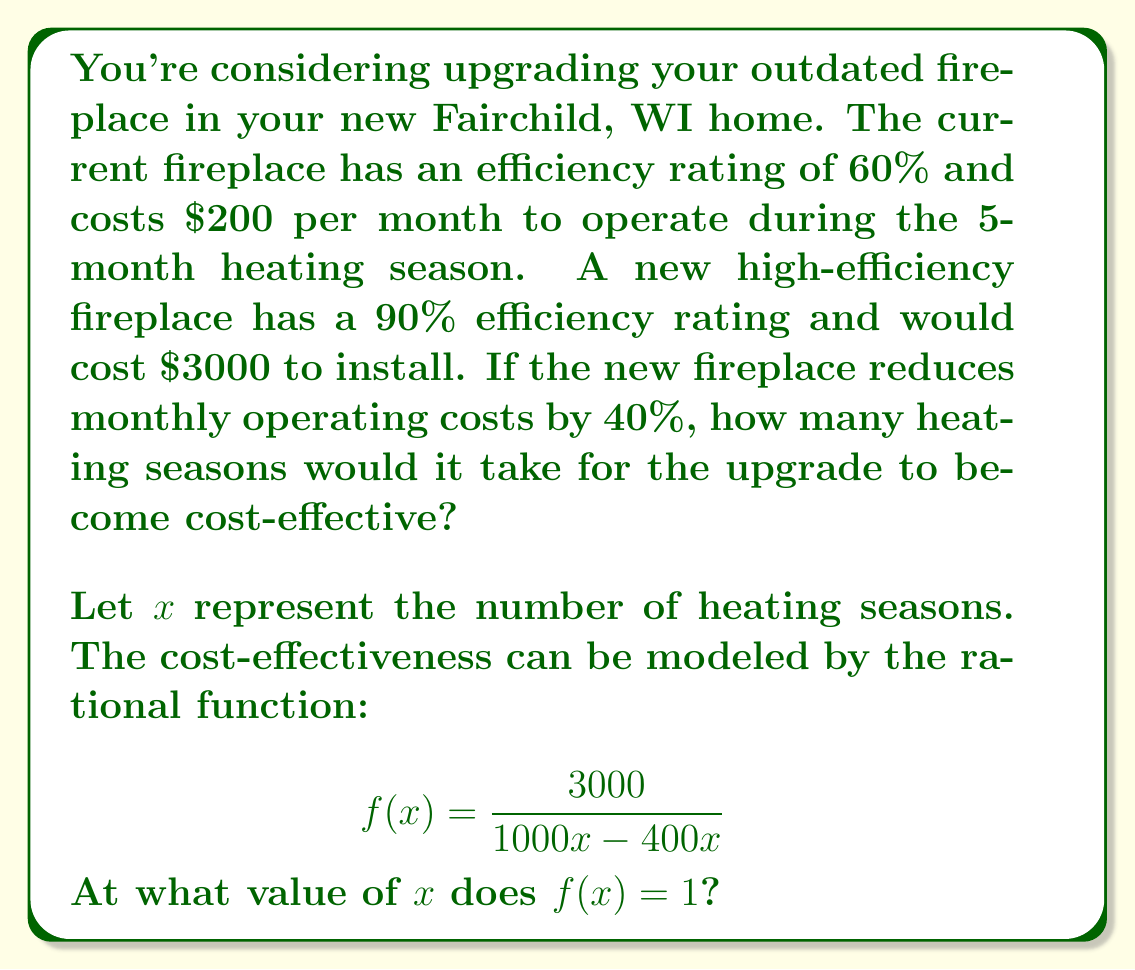What is the answer to this math problem? Let's approach this step-by-step:

1) First, let's calculate the current annual operating cost:
   $200 per month * 5 months = $1000 per year

2) The new fireplace would reduce operating costs by 40%:
   New annual operating cost = $1000 * (1 - 0.40) = $600

3) Annual savings: $1000 - $600 = $400

4) The rational function $f(x) = \frac{3000}{1000x - 400x}$ represents the ratio of the installation cost to the cumulative savings over $x$ heating seasons.

5) We want to find when this ratio equals 1, i.e., when the cumulative savings equal the installation cost:

   $$\frac{3000}{1000x - 400x} = 1$$

6) Multiply both sides by $(1000x - 400x)$:
   
   $$3000 = 1000x - 400x = 600x$$

7) Divide both sides by 600:

   $$5 = x$$

Therefore, it would take 5 heating seasons for the upgrade to become cost-effective.
Answer: 5 heating seasons 